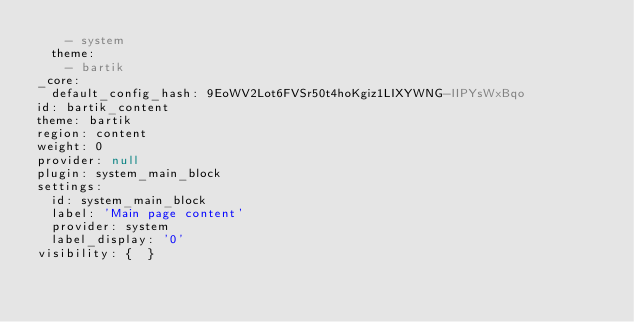<code> <loc_0><loc_0><loc_500><loc_500><_YAML_>    - system
  theme:
    - bartik
_core:
  default_config_hash: 9EoWV2Lot6FVSr50t4hoKgiz1LIXYWNG-IIPYsWxBqo
id: bartik_content
theme: bartik
region: content
weight: 0
provider: null
plugin: system_main_block
settings:
  id: system_main_block
  label: 'Main page content'
  provider: system
  label_display: '0'
visibility: {  }
</code> 